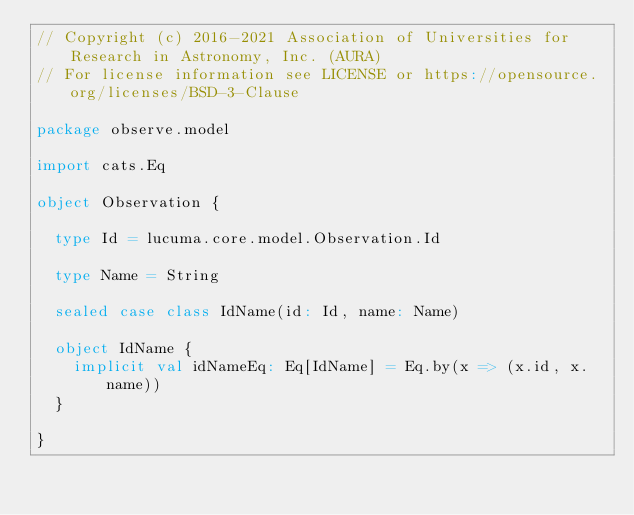Convert code to text. <code><loc_0><loc_0><loc_500><loc_500><_Scala_>// Copyright (c) 2016-2021 Association of Universities for Research in Astronomy, Inc. (AURA)
// For license information see LICENSE or https://opensource.org/licenses/BSD-3-Clause

package observe.model

import cats.Eq

object Observation {

  type Id = lucuma.core.model.Observation.Id

  type Name = String

  sealed case class IdName(id: Id, name: Name)

  object IdName {
    implicit val idNameEq: Eq[IdName] = Eq.by(x => (x.id, x.name))
  }

}
</code> 